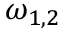<formula> <loc_0><loc_0><loc_500><loc_500>\omega _ { 1 , 2 }</formula> 